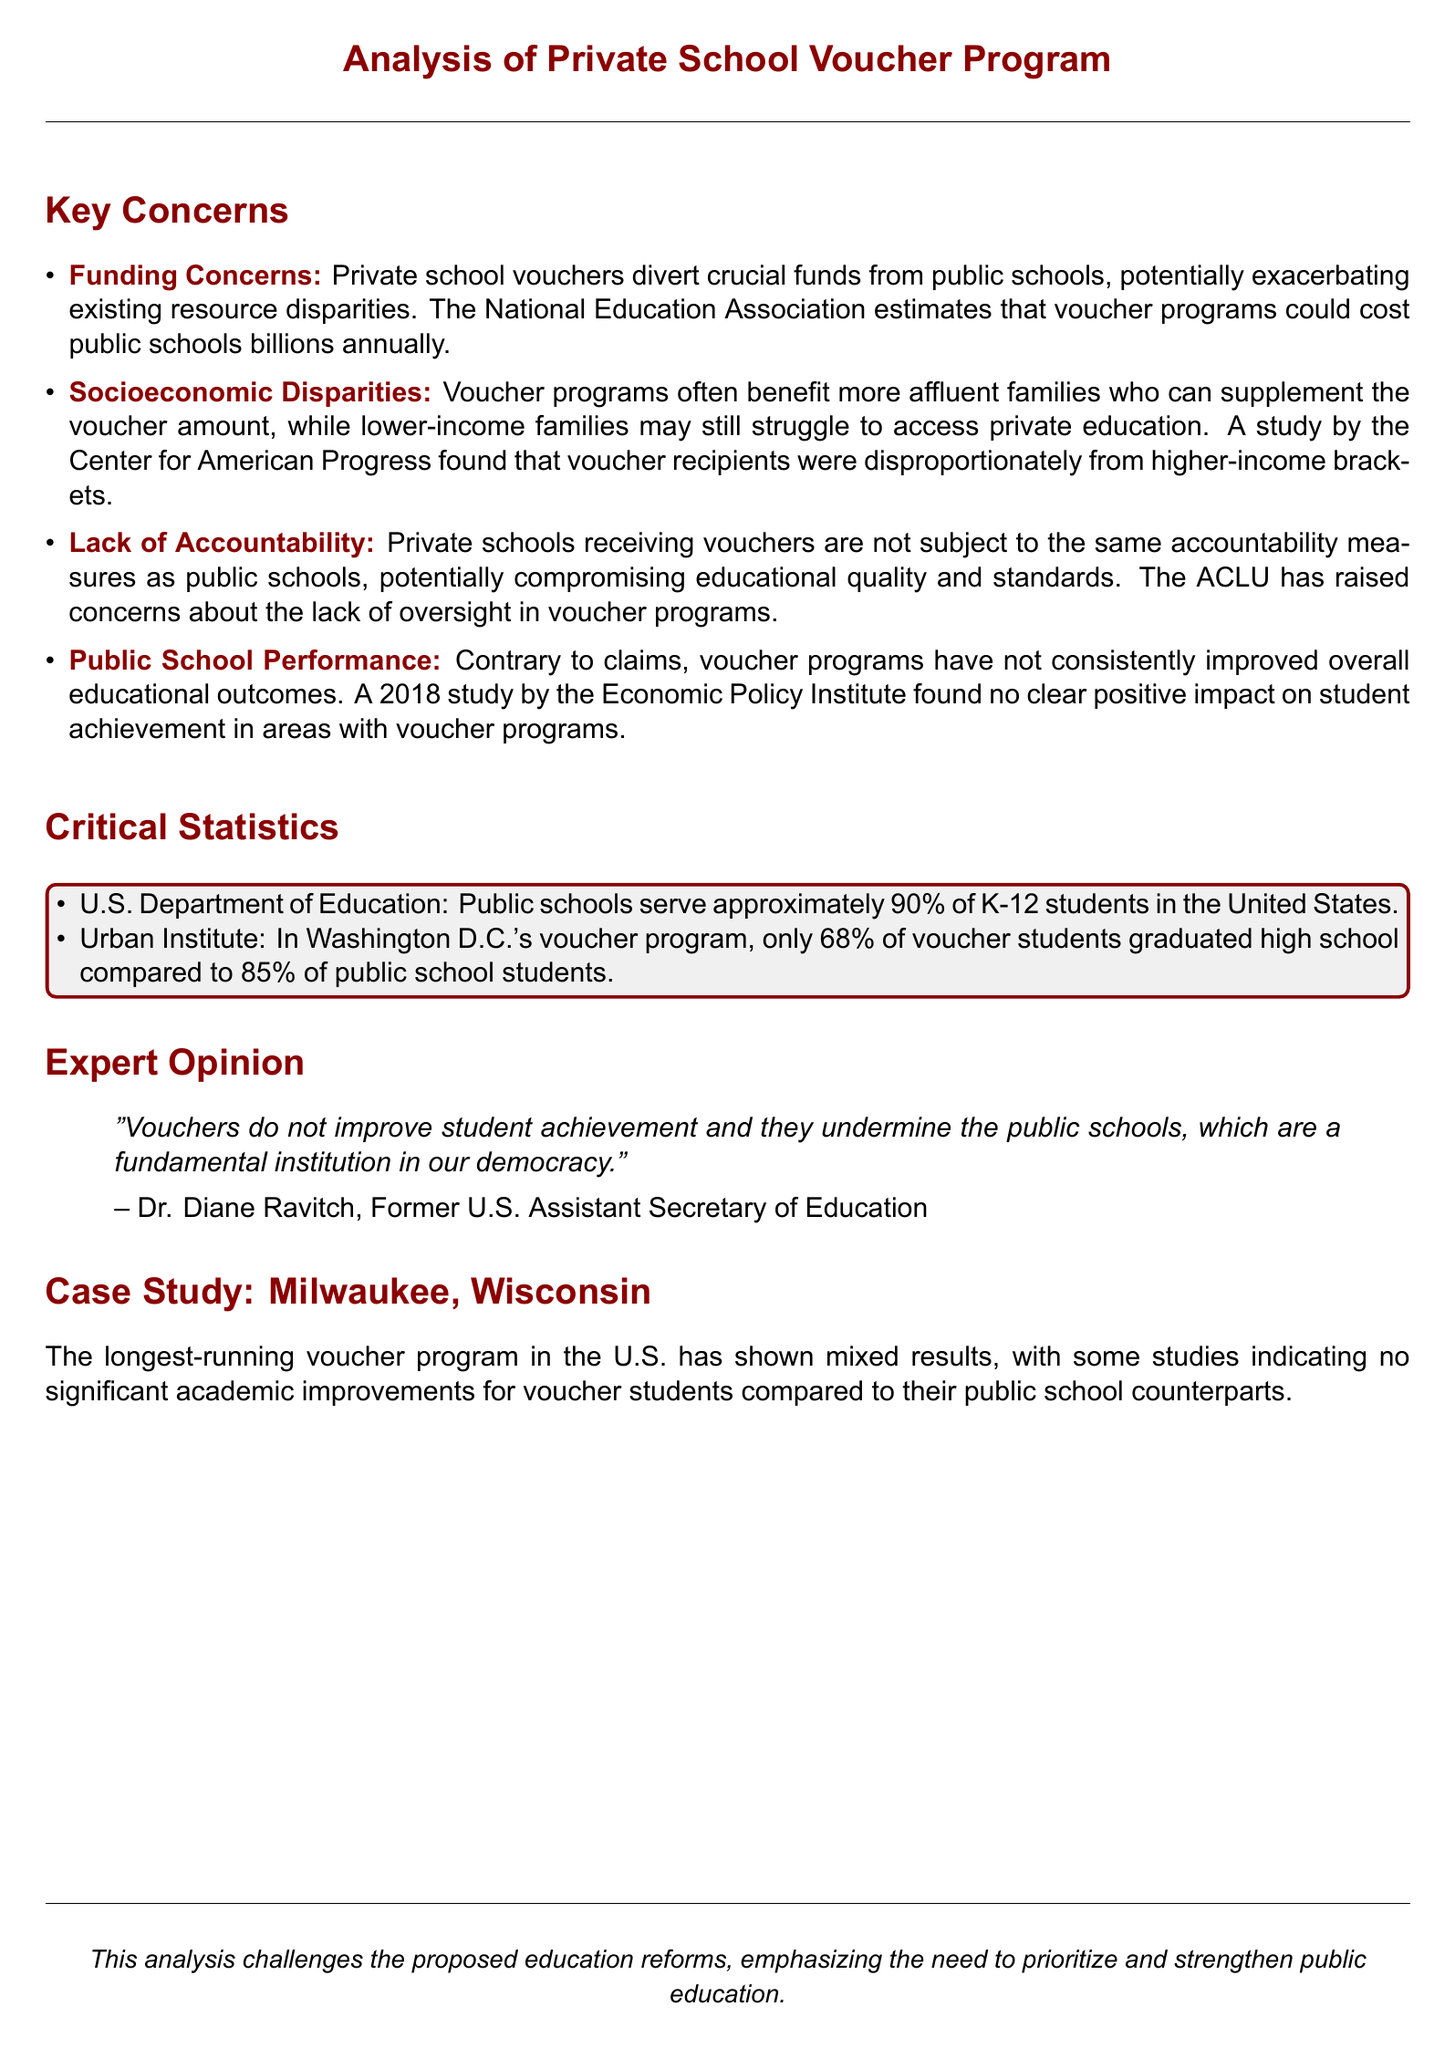What is the potential annual cost of voucher programs to public schools? The document states that voucher programs could cost public schools billions annually.
Answer: billions Which organization estimates the cost of voucher programs? The National Education Association estimates that voucher programs could cost public schools billions annually.
Answer: National Education Association What percentage of K-12 students are served by public schools in the U.S.? The document mentions that public schools serve approximately 90% of K-12 students in the United States.
Answer: 90% What was the graduation rate of voucher students in Washington D.C.'s program? According to the document, only 68% of voucher students graduated high school.
Answer: 68% Who is quoted in the document regarding the impact of vouchers? The document includes Dr. Diane Ravitch's opinion on vouchers and education.
Answer: Dr. Diane Ravitch What are the socioeconomic characteristics of voucher recipients according to the Center for American Progress? The study found that voucher recipients were disproportionately from higher-income brackets.
Answer: higher-income brackets What is the main case study mentioned in the document? The document highlights the longest-running voucher program in the U.S., which is based in Milwaukee, Wisconsin.
Answer: Milwaukee, Wisconsin What is the primary argument emphasized in the analysis? The analysis emphasizes the need to prioritize and strengthen public education.
Answer: strengthen public education What is one consequence of private schools receiving vouchers? The document states that private schools receiving vouchers are not subject to the same accountability measures as public schools.
Answer: lack of accountability 